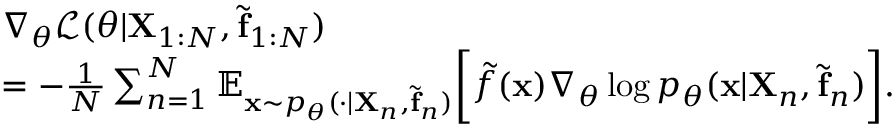Convert formula to latex. <formula><loc_0><loc_0><loc_500><loc_500>\begin{array} { r l } & { \nabla _ { \theta } \mathcal { L } ( \theta | X _ { 1 \colon N } , \tilde { f } _ { 1 \colon N } ) } \\ & { = - \frac { 1 } { N } \sum _ { n = 1 } ^ { N } \mathbb { E } _ { x \sim p _ { \theta } ( \cdot | X _ { n } , \tilde { f } _ { n } ) } \left [ \tilde { f } ( x ) \nabla _ { \theta } \log p _ { \theta } ( x | X _ { n } , \tilde { f } _ { n } ) \right ] . } \end{array}</formula> 